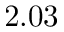Convert formula to latex. <formula><loc_0><loc_0><loc_500><loc_500>2 . 0 3</formula> 